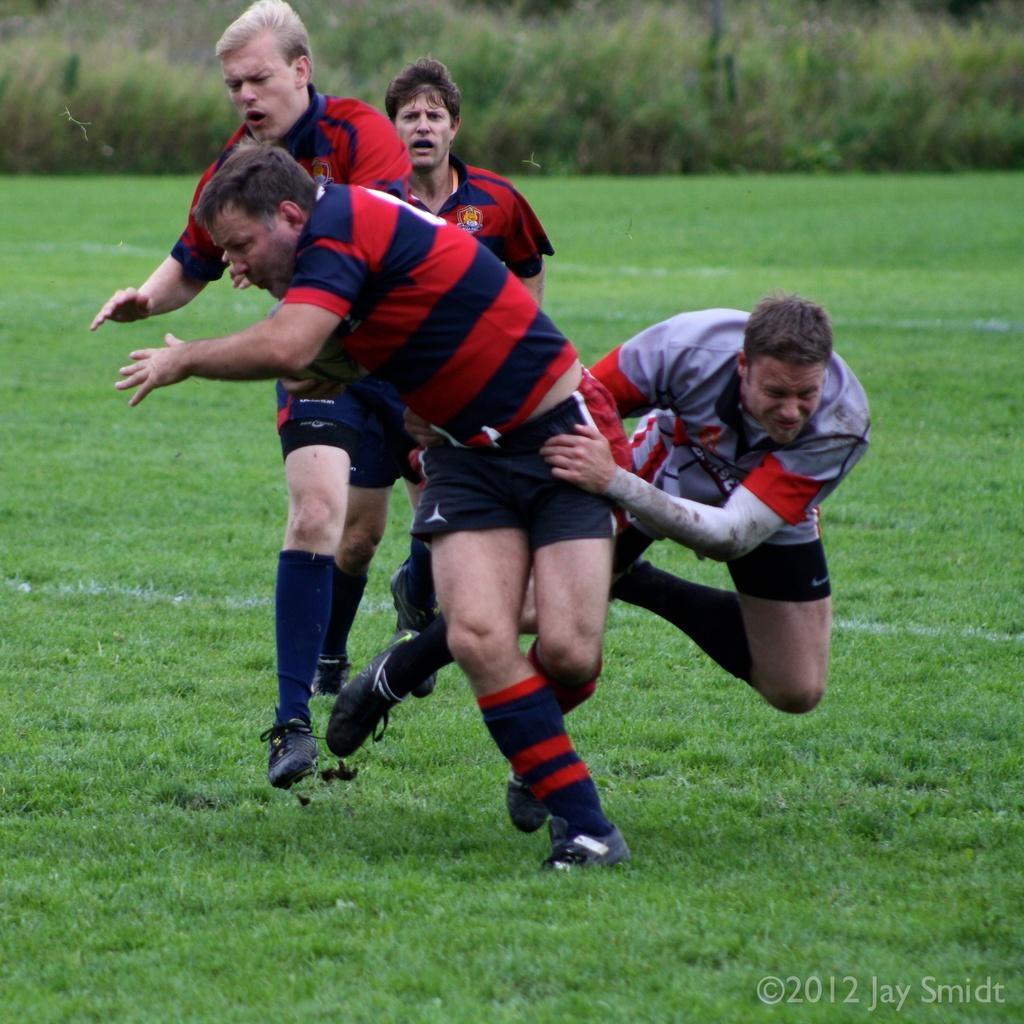How many people are in the image? There are four persons in the image. What are the persons doing in the image? The persons are playing in the ground. What is the surface they are playing on? The ground is covered with grass. What can be seen in the background of the image? There are plants visible in the background of the image. What type of butter is being used by the persons in the image? There is no butter present in the image; the persons are playing on a grass-covered ground. 